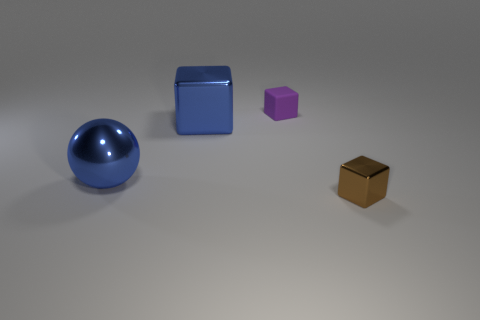What is the material of the block that is the same color as the large ball?
Make the answer very short. Metal. What material is the cube that is in front of the tiny rubber object and on the left side of the brown thing?
Make the answer very short. Metal. What number of things are either large cubes or metal blocks?
Offer a terse response. 2. Is the number of big cubes greater than the number of small blue rubber spheres?
Offer a terse response. Yes. What is the size of the block that is left of the tiny object behind the brown cube?
Your response must be concise. Large. What is the color of the other big object that is the same shape as the purple thing?
Your answer should be very brief. Blue. What size is the brown object?
Your answer should be compact. Small. How many blocks are either blue objects or small purple things?
Give a very brief answer. 2. What is the size of the blue metallic object that is the same shape as the matte thing?
Your answer should be very brief. Large. What number of matte cubes are there?
Offer a very short reply. 1. 